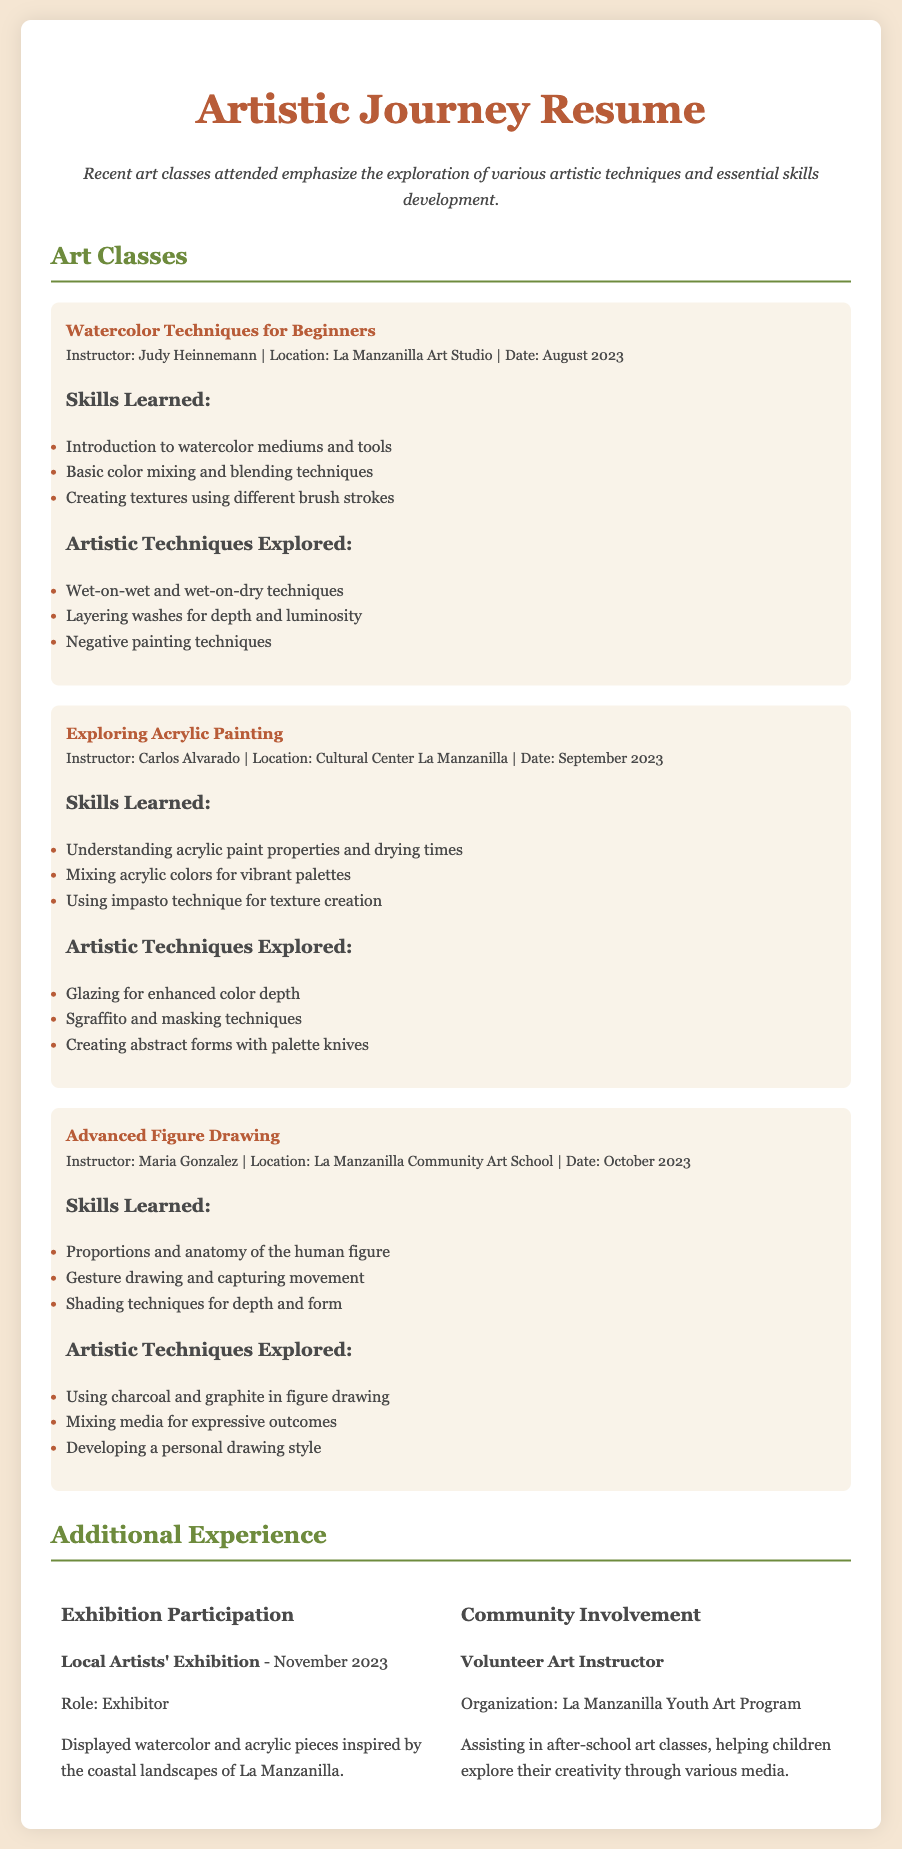What is the title of the first class attended? The title of the first class is mentioned in the document under "Art Classes."
Answer: Watercolor Techniques for Beginners Who was the instructor for the acrylic painting class? The document lists the instructor for the acrylic painting class in the respective section.
Answer: Carlos Alvarado What artistic technique is used for creating textures in the watercolor class? The document specifies the techniques learned in the watercolor class, including texture creation.
Answer: Different brush strokes In which month did the advanced figure drawing class take place? The date of the advanced figure drawing class is included in the class details section.
Answer: October What type of painting techniques were explored in the acrylic class? The document lists several techniques explored in the acrylic class, combining various methods.
Answer: Glazing, Sgraffito, Masking How many art classes are listed in the document? The total number of classes can be counted based on the sections provided in the document.
Answer: Three What role did the participant have in the local artists' exhibition? The document mentions the role in the exhibition under the "Additional Experience" section.
Answer: Exhibitor Which organization is associated with the volunteer art instructor experience? The organization for the volunteer role is specifically noted in the community involvement section.
Answer: La Manzanilla Youth Art Program What is the summary of the recent art classes attended? The summary provides an overview of the focus of the classes regarding skills and techniques.
Answer: Emphasize the exploration of various artistic techniques and essential skills development 